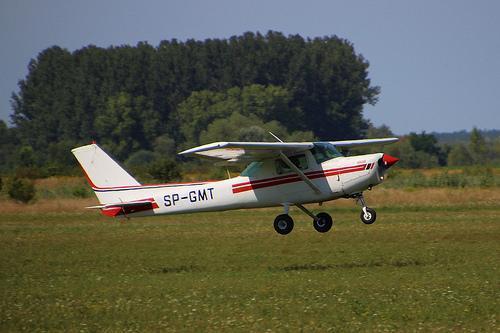How many planes are pictured?
Give a very brief answer. 1. How many of the plane's wheels are touching the ground?
Give a very brief answer. 0. How many tires do you see?
Give a very brief answer. 3. 